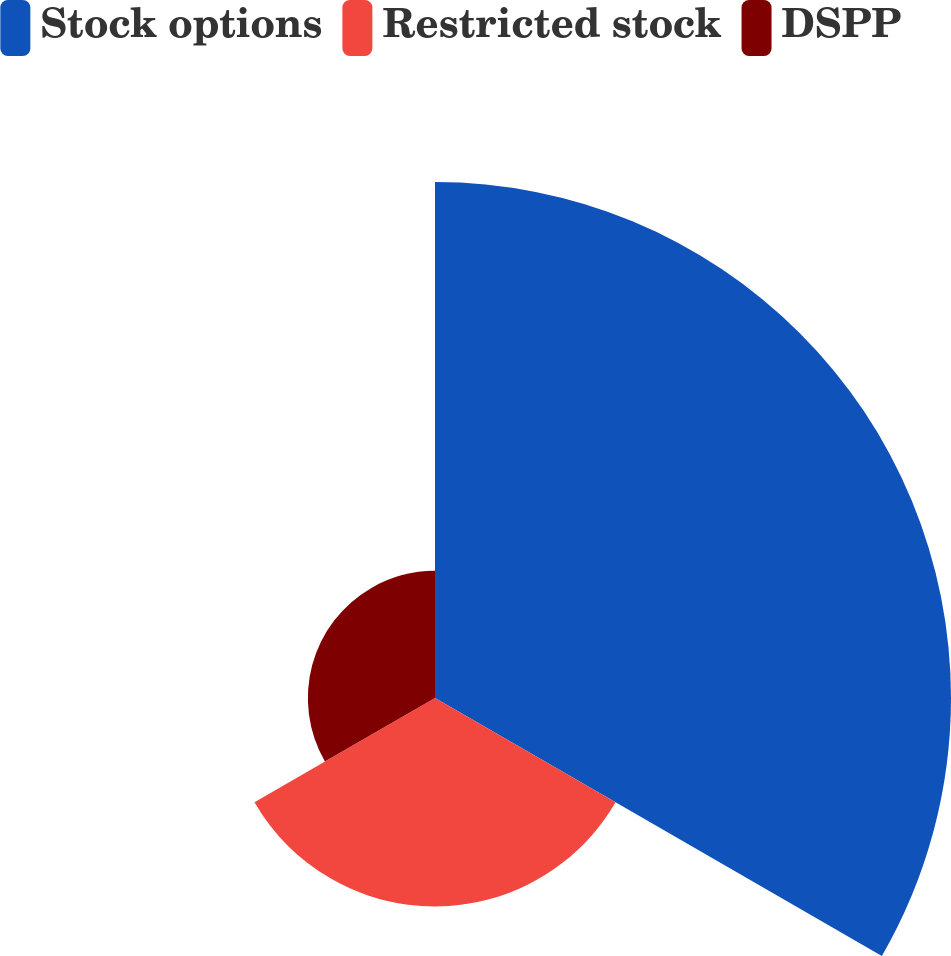Convert chart. <chart><loc_0><loc_0><loc_500><loc_500><pie_chart><fcel>Stock options<fcel>Restricted stock<fcel>DSPP<nl><fcel>60.6%<fcel>24.48%<fcel>14.93%<nl></chart> 